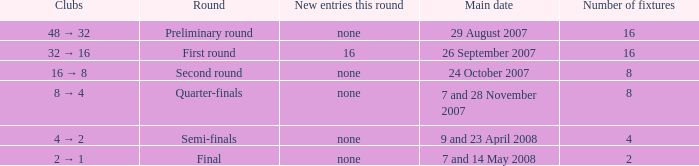What is the sum of Number of fixtures when the rounds shows quarter-finals? 8.0. 